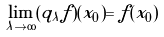Convert formula to latex. <formula><loc_0><loc_0><loc_500><loc_500>\lim _ { \lambda \to \infty } ( q _ { \lambda } f ) ( x _ { 0 } ) = f ( x _ { 0 } )</formula> 